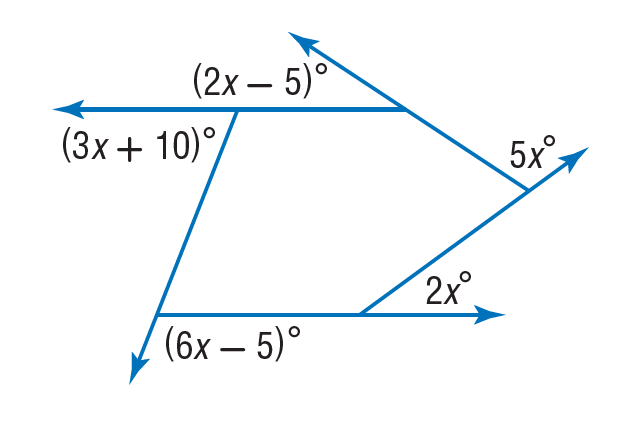Answer the mathemtical geometry problem and directly provide the correct option letter.
Question: Find the value of x in the diagram.
Choices: A: 5 B: 10 C: 20 D: 40 C 